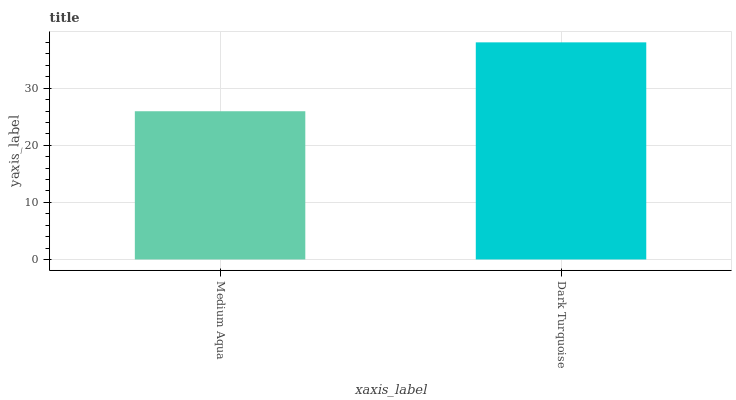Is Medium Aqua the minimum?
Answer yes or no. Yes. Is Dark Turquoise the maximum?
Answer yes or no. Yes. Is Dark Turquoise the minimum?
Answer yes or no. No. Is Dark Turquoise greater than Medium Aqua?
Answer yes or no. Yes. Is Medium Aqua less than Dark Turquoise?
Answer yes or no. Yes. Is Medium Aqua greater than Dark Turquoise?
Answer yes or no. No. Is Dark Turquoise less than Medium Aqua?
Answer yes or no. No. Is Dark Turquoise the high median?
Answer yes or no. Yes. Is Medium Aqua the low median?
Answer yes or no. Yes. Is Medium Aqua the high median?
Answer yes or no. No. Is Dark Turquoise the low median?
Answer yes or no. No. 